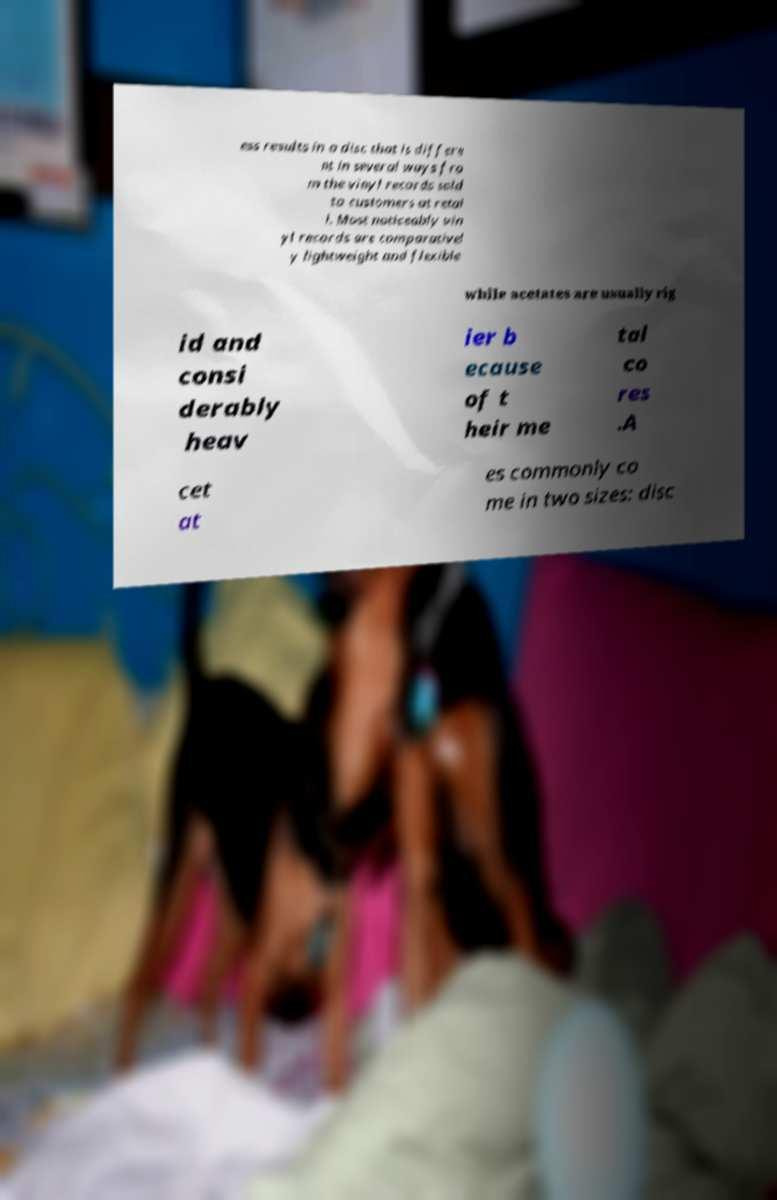I need the written content from this picture converted into text. Can you do that? ess results in a disc that is differe nt in several ways fro m the vinyl records sold to customers at retai l. Most noticeably vin yl records are comparativel y lightweight and flexible while acetates are usually rig id and consi derably heav ier b ecause of t heir me tal co res .A cet at es commonly co me in two sizes: disc 